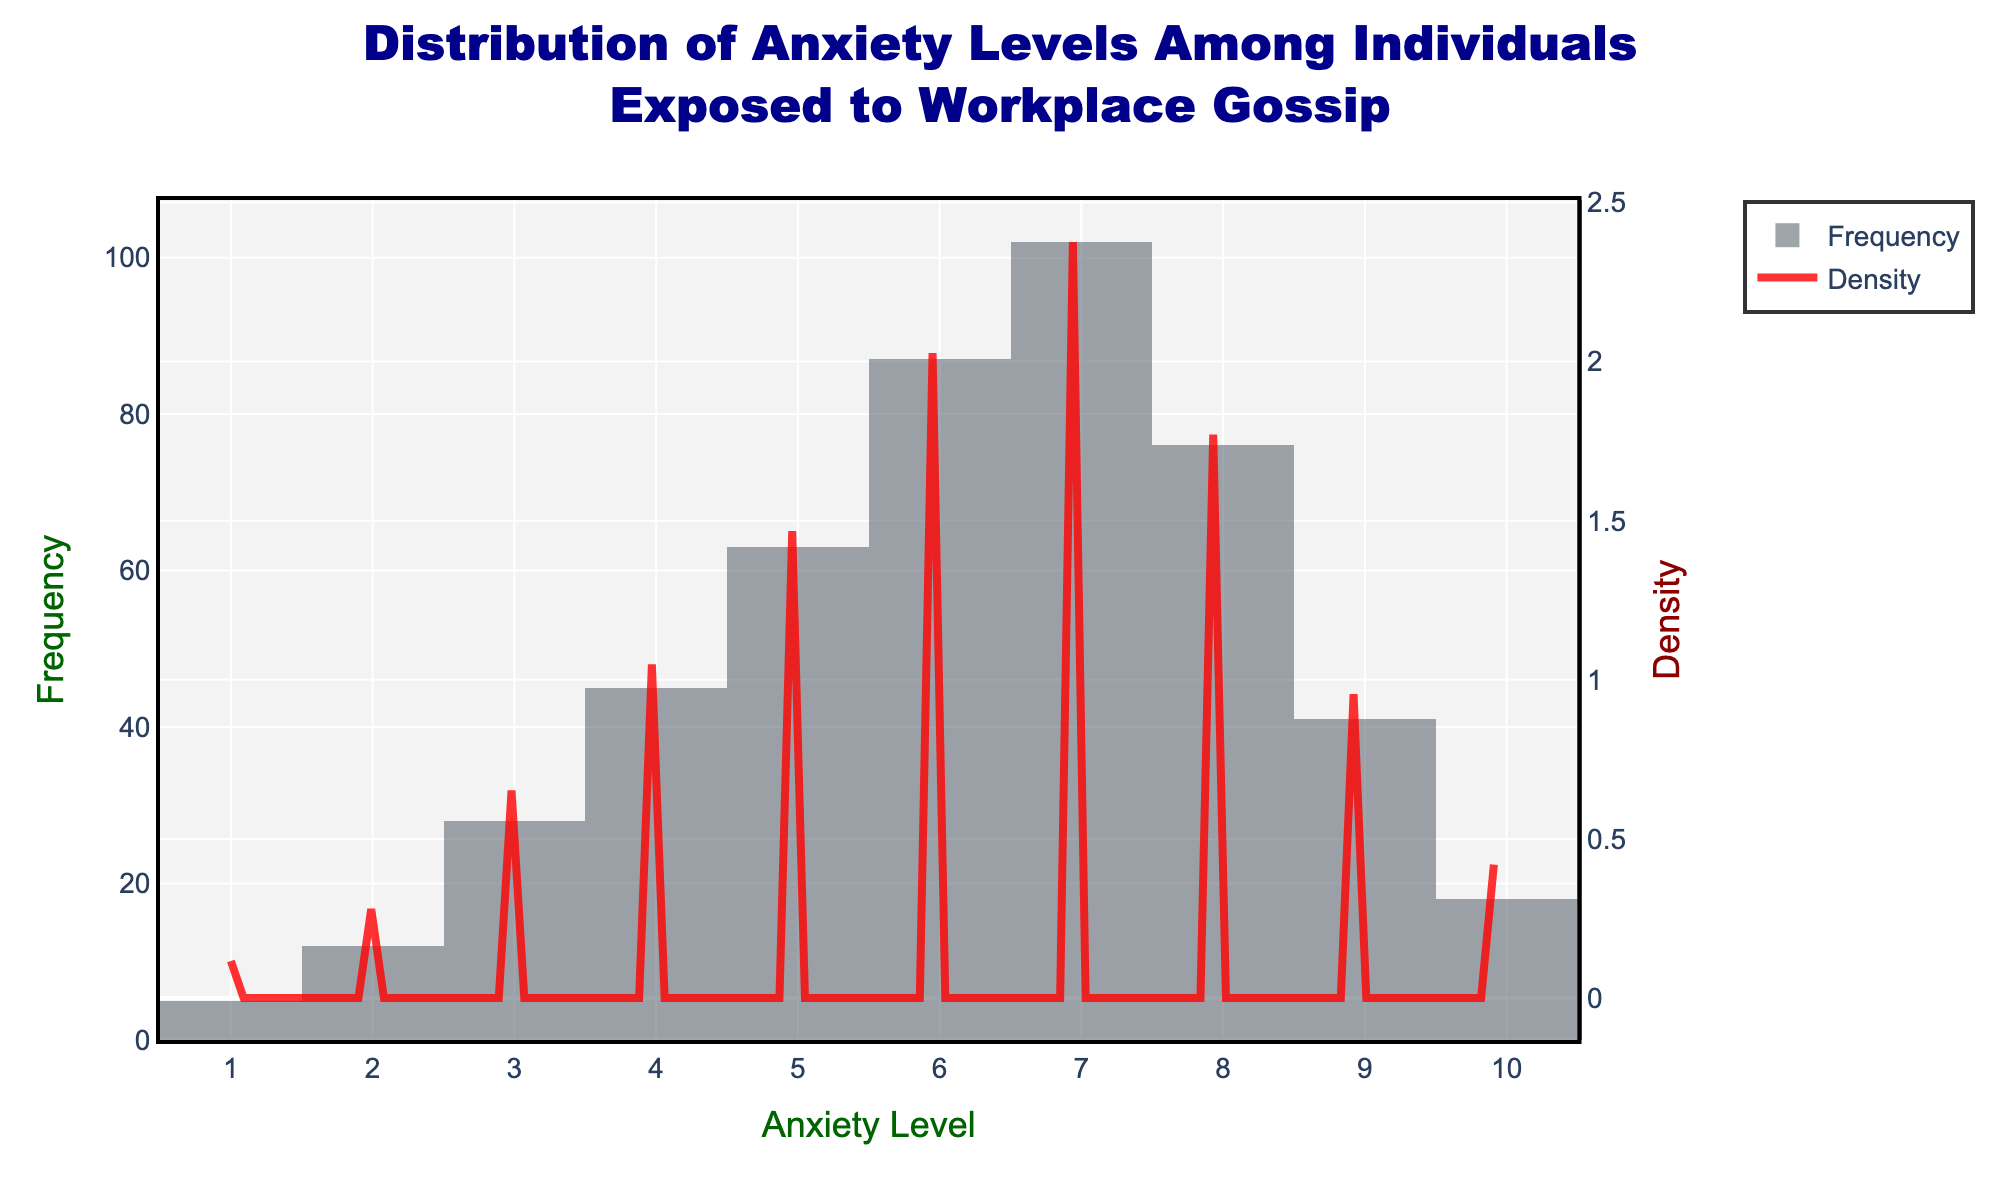What is the title of the figure? The title is detailed in the largest font at the top of the figure. It reads, "Distribution of Anxiety Levels Among Individuals Exposed to Workplace Gossip".
Answer: Distribution of Anxiety Levels Among Individuals Exposed to Workplace Gossip What is the range of anxiety levels displayed on the x-axis? The x-axis represents the anxiety levels and is labeled from 1 to 10, as indicated by the tick marks and axis labels.
Answer: 1 to 10 Which anxiety level has the highest frequency? By observing the height of the bars in the histogram, the tallest bar corresponds to the anxiety level of 7, indicating it has the highest frequency.
Answer: 7 Between which anxiety levels is the density the highest? The density curve shows its peak between anxiety levels 6 and 7, meaning the density of anxiety levels is the highest in this range.
Answer: 6 and 7 What are the colors used to represent the frequency and density curves? The frequency is shown in dark grey bars, while the density curve is represented by a red line.
Answer: Dark grey and red What is the average anxiety level among individuals? To find the average, multiply each anxiety level by its frequency, sum these products, and then divide by the total number of individuals: \((1*5 + 2*12 + 3*28 + 4*45 + 5*63 + 6*87 + 7*102 + 8*76 + 9*41 + 10*18) / (5+12+28+45+63+87+102+76+41+18)\).
Answer: 6 How does the frequency at anxiety level 4 compare to anxiety level 9? The frequency at anxiety level 4 is 45, while at anxiety level 9, it is 41. Thus, the frequency at anxiety level 4 is slightly higher than at 9.
Answer: Higher What is the frequency range depicted on the y-axis (left)? Looking at the y-axis on the left, which represents the frequency, the values range from 0 up to slightly above 100, according to the highest bar in the histogram.
Answer: 0 to around 100 Describe the secondary y-axis (right) and its significance in the chart. The secondary y-axis on the right indicates the density. It is crucial for understanding the probability distribution of anxiety levels, shown by the red density curve.
Answer: Density What is the significance of adding a KDE (density curve) to the histogram in this context? Adding the KDE to the histogram provides a smoothed estimate of the continuous distribution of anxiety levels, making it easier to visualize where the data is concentrated and understand the overall pattern.
Answer: Shows data concentration 